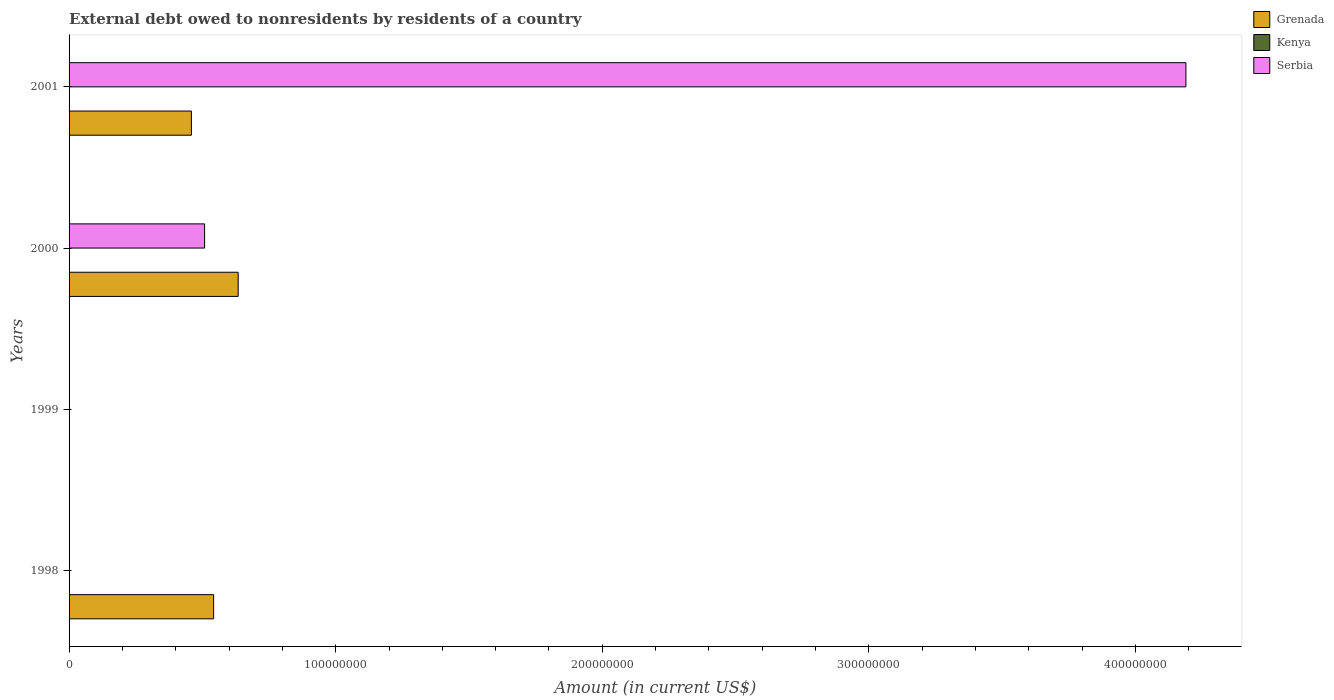Are the number of bars per tick equal to the number of legend labels?
Offer a terse response. No. Are the number of bars on each tick of the Y-axis equal?
Make the answer very short. No. How many bars are there on the 2nd tick from the top?
Make the answer very short. 2. How many bars are there on the 4th tick from the bottom?
Offer a very short reply. 2. What is the label of the 1st group of bars from the top?
Ensure brevity in your answer.  2001. What is the external debt owed by residents in Grenada in 1998?
Provide a short and direct response. 5.42e+07. Across all years, what is the maximum external debt owed by residents in Serbia?
Your answer should be very brief. 4.19e+08. Across all years, what is the minimum external debt owed by residents in Serbia?
Give a very brief answer. 0. What is the total external debt owed by residents in Serbia in the graph?
Provide a short and direct response. 4.70e+08. What is the difference between the external debt owed by residents in Grenada in 2000 and that in 2001?
Ensure brevity in your answer.  1.75e+07. What is the difference between the external debt owed by residents in Serbia in 1998 and the external debt owed by residents in Kenya in 2001?
Your response must be concise. 0. What is the average external debt owed by residents in Kenya per year?
Your response must be concise. 0. In the year 2001, what is the difference between the external debt owed by residents in Serbia and external debt owed by residents in Grenada?
Give a very brief answer. 3.73e+08. In how many years, is the external debt owed by residents in Serbia greater than 220000000 US$?
Offer a terse response. 1. What is the ratio of the external debt owed by residents in Grenada in 1998 to that in 2000?
Give a very brief answer. 0.85. Is the difference between the external debt owed by residents in Serbia in 2000 and 2001 greater than the difference between the external debt owed by residents in Grenada in 2000 and 2001?
Provide a short and direct response. No. What is the difference between the highest and the second highest external debt owed by residents in Grenada?
Your response must be concise. 9.20e+06. What is the difference between the highest and the lowest external debt owed by residents in Serbia?
Make the answer very short. 4.19e+08. In how many years, is the external debt owed by residents in Kenya greater than the average external debt owed by residents in Kenya taken over all years?
Your response must be concise. 0. How many bars are there?
Provide a succinct answer. 5. How many years are there in the graph?
Offer a very short reply. 4. What is the difference between two consecutive major ticks on the X-axis?
Provide a succinct answer. 1.00e+08. Does the graph contain grids?
Offer a very short reply. No. Where does the legend appear in the graph?
Provide a short and direct response. Top right. How are the legend labels stacked?
Provide a short and direct response. Vertical. What is the title of the graph?
Offer a terse response. External debt owed to nonresidents by residents of a country. Does "Morocco" appear as one of the legend labels in the graph?
Provide a succinct answer. No. What is the Amount (in current US$) of Grenada in 1998?
Ensure brevity in your answer.  5.42e+07. What is the Amount (in current US$) in Kenya in 1998?
Offer a very short reply. 0. What is the Amount (in current US$) of Serbia in 1998?
Give a very brief answer. 0. What is the Amount (in current US$) in Grenada in 1999?
Make the answer very short. 0. What is the Amount (in current US$) in Serbia in 1999?
Your answer should be very brief. 0. What is the Amount (in current US$) in Grenada in 2000?
Your answer should be very brief. 6.34e+07. What is the Amount (in current US$) in Kenya in 2000?
Your response must be concise. 0. What is the Amount (in current US$) of Serbia in 2000?
Your answer should be compact. 5.08e+07. What is the Amount (in current US$) of Grenada in 2001?
Offer a very short reply. 4.59e+07. What is the Amount (in current US$) in Kenya in 2001?
Provide a short and direct response. 0. What is the Amount (in current US$) of Serbia in 2001?
Your answer should be very brief. 4.19e+08. Across all years, what is the maximum Amount (in current US$) in Grenada?
Provide a short and direct response. 6.34e+07. Across all years, what is the maximum Amount (in current US$) of Serbia?
Ensure brevity in your answer.  4.19e+08. What is the total Amount (in current US$) in Grenada in the graph?
Make the answer very short. 1.64e+08. What is the total Amount (in current US$) of Serbia in the graph?
Provide a succinct answer. 4.70e+08. What is the difference between the Amount (in current US$) of Grenada in 1998 and that in 2000?
Your response must be concise. -9.20e+06. What is the difference between the Amount (in current US$) of Grenada in 1998 and that in 2001?
Keep it short and to the point. 8.33e+06. What is the difference between the Amount (in current US$) of Grenada in 2000 and that in 2001?
Your answer should be compact. 1.75e+07. What is the difference between the Amount (in current US$) in Serbia in 2000 and that in 2001?
Offer a very short reply. -3.68e+08. What is the difference between the Amount (in current US$) in Grenada in 1998 and the Amount (in current US$) in Serbia in 2000?
Your response must be concise. 3.39e+06. What is the difference between the Amount (in current US$) in Grenada in 1998 and the Amount (in current US$) in Serbia in 2001?
Offer a terse response. -3.65e+08. What is the difference between the Amount (in current US$) in Grenada in 2000 and the Amount (in current US$) in Serbia in 2001?
Keep it short and to the point. -3.55e+08. What is the average Amount (in current US$) of Grenada per year?
Provide a succinct answer. 4.09e+07. What is the average Amount (in current US$) of Serbia per year?
Your answer should be compact. 1.17e+08. In the year 2000, what is the difference between the Amount (in current US$) in Grenada and Amount (in current US$) in Serbia?
Make the answer very short. 1.26e+07. In the year 2001, what is the difference between the Amount (in current US$) of Grenada and Amount (in current US$) of Serbia?
Provide a succinct answer. -3.73e+08. What is the ratio of the Amount (in current US$) in Grenada in 1998 to that in 2000?
Provide a short and direct response. 0.85. What is the ratio of the Amount (in current US$) of Grenada in 1998 to that in 2001?
Your response must be concise. 1.18. What is the ratio of the Amount (in current US$) in Grenada in 2000 to that in 2001?
Your answer should be compact. 1.38. What is the ratio of the Amount (in current US$) in Serbia in 2000 to that in 2001?
Provide a short and direct response. 0.12. What is the difference between the highest and the second highest Amount (in current US$) of Grenada?
Give a very brief answer. 9.20e+06. What is the difference between the highest and the lowest Amount (in current US$) of Grenada?
Your answer should be compact. 6.34e+07. What is the difference between the highest and the lowest Amount (in current US$) in Serbia?
Make the answer very short. 4.19e+08. 